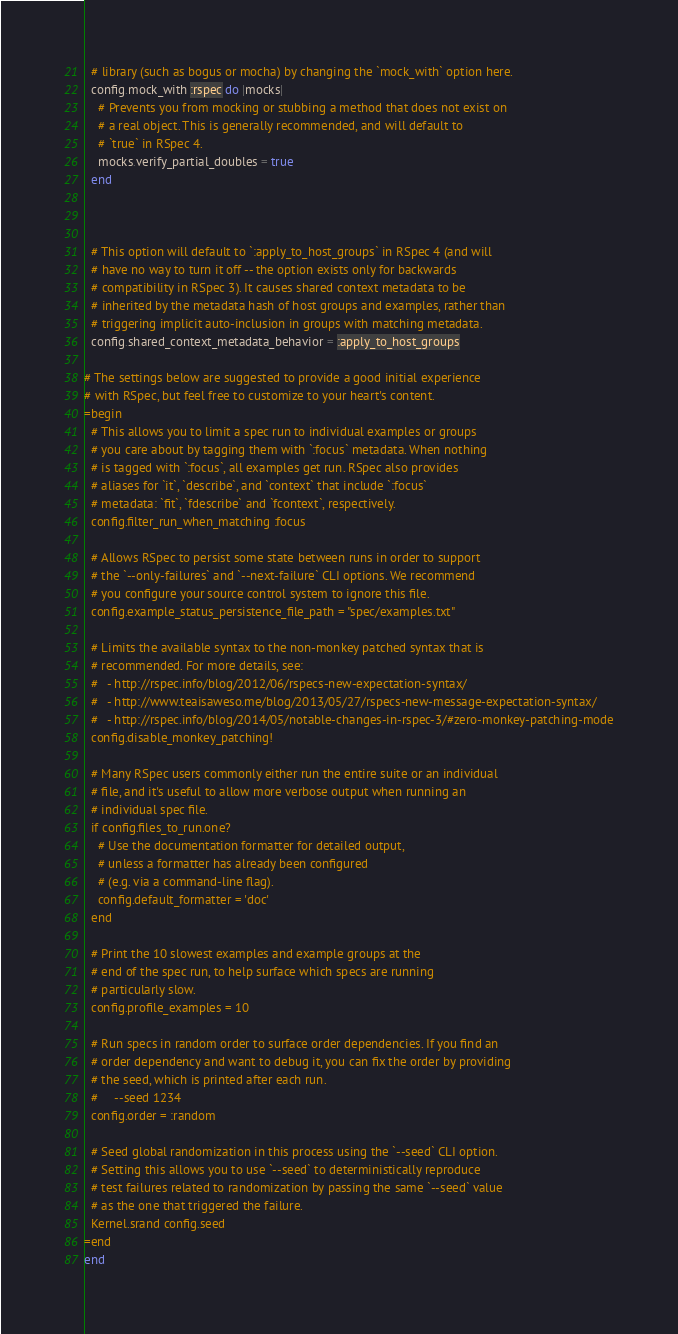Convert code to text. <code><loc_0><loc_0><loc_500><loc_500><_Ruby_>  # library (such as bogus or mocha) by changing the `mock_with` option here.
  config.mock_with :rspec do |mocks|
    # Prevents you from mocking or stubbing a method that does not exist on
    # a real object. This is generally recommended, and will default to
    # `true` in RSpec 4.
    mocks.verify_partial_doubles = true
  end



  # This option will default to `:apply_to_host_groups` in RSpec 4 (and will
  # have no way to turn it off -- the option exists only for backwards
  # compatibility in RSpec 3). It causes shared context metadata to be
  # inherited by the metadata hash of host groups and examples, rather than
  # triggering implicit auto-inclusion in groups with matching metadata.
  config.shared_context_metadata_behavior = :apply_to_host_groups

# The settings below are suggested to provide a good initial experience
# with RSpec, but feel free to customize to your heart's content.
=begin
  # This allows you to limit a spec run to individual examples or groups
  # you care about by tagging them with `:focus` metadata. When nothing
  # is tagged with `:focus`, all examples get run. RSpec also provides
  # aliases for `it`, `describe`, and `context` that include `:focus`
  # metadata: `fit`, `fdescribe` and `fcontext`, respectively.
  config.filter_run_when_matching :focus

  # Allows RSpec to persist some state between runs in order to support
  # the `--only-failures` and `--next-failure` CLI options. We recommend
  # you configure your source control system to ignore this file.
  config.example_status_persistence_file_path = "spec/examples.txt"

  # Limits the available syntax to the non-monkey patched syntax that is
  # recommended. For more details, see:
  #   - http://rspec.info/blog/2012/06/rspecs-new-expectation-syntax/
  #   - http://www.teaisaweso.me/blog/2013/05/27/rspecs-new-message-expectation-syntax/
  #   - http://rspec.info/blog/2014/05/notable-changes-in-rspec-3/#zero-monkey-patching-mode
  config.disable_monkey_patching!

  # Many RSpec users commonly either run the entire suite or an individual
  # file, and it's useful to allow more verbose output when running an
  # individual spec file.
  if config.files_to_run.one?
    # Use the documentation formatter for detailed output,
    # unless a formatter has already been configured
    # (e.g. via a command-line flag).
    config.default_formatter = 'doc'
  end

  # Print the 10 slowest examples and example groups at the
  # end of the spec run, to help surface which specs are running
  # particularly slow.
  config.profile_examples = 10

  # Run specs in random order to surface order dependencies. If you find an
  # order dependency and want to debug it, you can fix the order by providing
  # the seed, which is printed after each run.
  #     --seed 1234
  config.order = :random

  # Seed global randomization in this process using the `--seed` CLI option.
  # Setting this allows you to use `--seed` to deterministically reproduce
  # test failures related to randomization by passing the same `--seed` value
  # as the one that triggered the failure.
  Kernel.srand config.seed
=end
end
</code> 